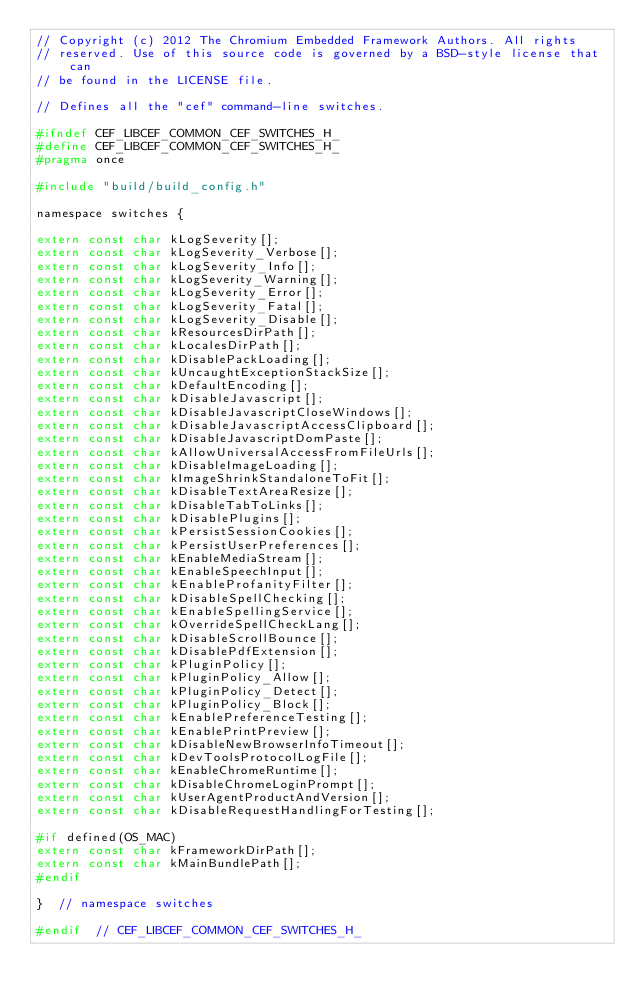<code> <loc_0><loc_0><loc_500><loc_500><_C_>// Copyright (c) 2012 The Chromium Embedded Framework Authors. All rights
// reserved. Use of this source code is governed by a BSD-style license that can
// be found in the LICENSE file.

// Defines all the "cef" command-line switches.

#ifndef CEF_LIBCEF_COMMON_CEF_SWITCHES_H_
#define CEF_LIBCEF_COMMON_CEF_SWITCHES_H_
#pragma once

#include "build/build_config.h"

namespace switches {

extern const char kLogSeverity[];
extern const char kLogSeverity_Verbose[];
extern const char kLogSeverity_Info[];
extern const char kLogSeverity_Warning[];
extern const char kLogSeverity_Error[];
extern const char kLogSeverity_Fatal[];
extern const char kLogSeverity_Disable[];
extern const char kResourcesDirPath[];
extern const char kLocalesDirPath[];
extern const char kDisablePackLoading[];
extern const char kUncaughtExceptionStackSize[];
extern const char kDefaultEncoding[];
extern const char kDisableJavascript[];
extern const char kDisableJavascriptCloseWindows[];
extern const char kDisableJavascriptAccessClipboard[];
extern const char kDisableJavascriptDomPaste[];
extern const char kAllowUniversalAccessFromFileUrls[];
extern const char kDisableImageLoading[];
extern const char kImageShrinkStandaloneToFit[];
extern const char kDisableTextAreaResize[];
extern const char kDisableTabToLinks[];
extern const char kDisablePlugins[];
extern const char kPersistSessionCookies[];
extern const char kPersistUserPreferences[];
extern const char kEnableMediaStream[];
extern const char kEnableSpeechInput[];
extern const char kEnableProfanityFilter[];
extern const char kDisableSpellChecking[];
extern const char kEnableSpellingService[];
extern const char kOverrideSpellCheckLang[];
extern const char kDisableScrollBounce[];
extern const char kDisablePdfExtension[];
extern const char kPluginPolicy[];
extern const char kPluginPolicy_Allow[];
extern const char kPluginPolicy_Detect[];
extern const char kPluginPolicy_Block[];
extern const char kEnablePreferenceTesting[];
extern const char kEnablePrintPreview[];
extern const char kDisableNewBrowserInfoTimeout[];
extern const char kDevToolsProtocolLogFile[];
extern const char kEnableChromeRuntime[];
extern const char kDisableChromeLoginPrompt[];
extern const char kUserAgentProductAndVersion[];
extern const char kDisableRequestHandlingForTesting[];

#if defined(OS_MAC)
extern const char kFrameworkDirPath[];
extern const char kMainBundlePath[];
#endif

}  // namespace switches

#endif  // CEF_LIBCEF_COMMON_CEF_SWITCHES_H_
</code> 